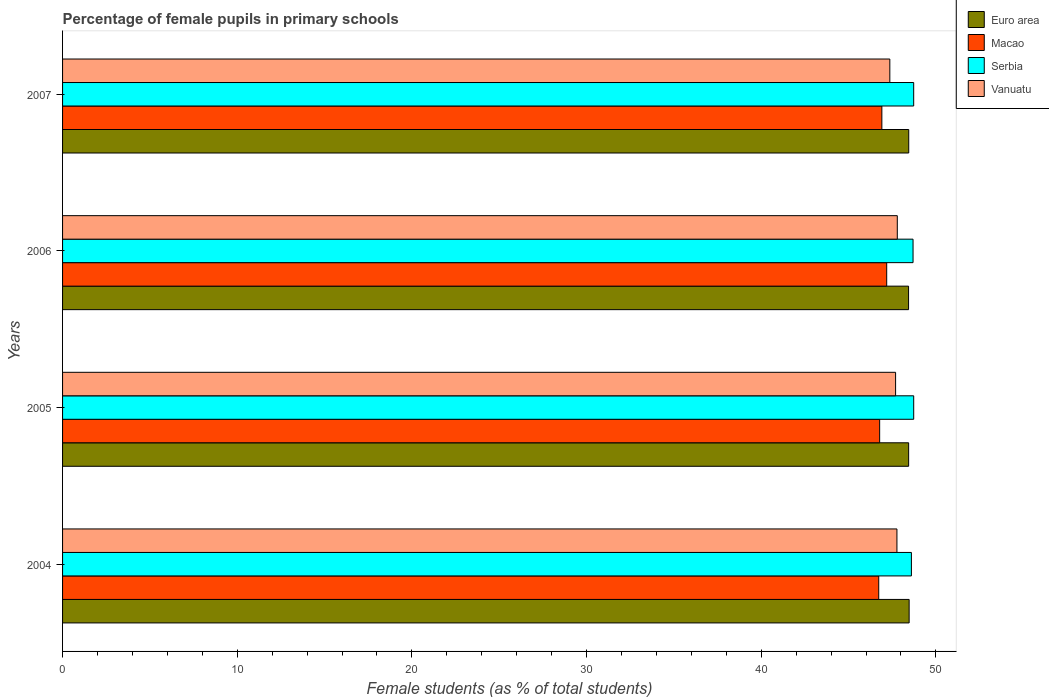How many groups of bars are there?
Provide a short and direct response. 4. How many bars are there on the 4th tick from the top?
Offer a terse response. 4. How many bars are there on the 1st tick from the bottom?
Your response must be concise. 4. What is the percentage of female pupils in primary schools in Macao in 2005?
Offer a terse response. 46.78. Across all years, what is the maximum percentage of female pupils in primary schools in Macao?
Provide a succinct answer. 47.18. Across all years, what is the minimum percentage of female pupils in primary schools in Vanuatu?
Give a very brief answer. 47.36. In which year was the percentage of female pupils in primary schools in Serbia maximum?
Offer a very short reply. 2005. In which year was the percentage of female pupils in primary schools in Euro area minimum?
Offer a very short reply. 2006. What is the total percentage of female pupils in primary schools in Serbia in the graph?
Offer a very short reply. 194.75. What is the difference between the percentage of female pupils in primary schools in Vanuatu in 2005 and that in 2007?
Provide a succinct answer. 0.33. What is the difference between the percentage of female pupils in primary schools in Vanuatu in 2005 and the percentage of female pupils in primary schools in Serbia in 2007?
Provide a short and direct response. -1.04. What is the average percentage of female pupils in primary schools in Macao per year?
Your answer should be very brief. 46.9. In the year 2005, what is the difference between the percentage of female pupils in primary schools in Euro area and percentage of female pupils in primary schools in Vanuatu?
Your answer should be very brief. 0.75. What is the ratio of the percentage of female pupils in primary schools in Vanuatu in 2005 to that in 2007?
Offer a very short reply. 1.01. What is the difference between the highest and the second highest percentage of female pupils in primary schools in Serbia?
Your answer should be very brief. 0. What is the difference between the highest and the lowest percentage of female pupils in primary schools in Serbia?
Offer a very short reply. 0.13. What does the 2nd bar from the top in 2006 represents?
Give a very brief answer. Serbia. What does the 3rd bar from the bottom in 2005 represents?
Keep it short and to the point. Serbia. How many bars are there?
Provide a short and direct response. 16. Does the graph contain any zero values?
Provide a short and direct response. No. Does the graph contain grids?
Provide a short and direct response. No. Where does the legend appear in the graph?
Your response must be concise. Top right. How are the legend labels stacked?
Ensure brevity in your answer.  Vertical. What is the title of the graph?
Ensure brevity in your answer.  Percentage of female pupils in primary schools. What is the label or title of the X-axis?
Your answer should be very brief. Female students (as % of total students). What is the Female students (as % of total students) in Euro area in 2004?
Provide a succinct answer. 48.47. What is the Female students (as % of total students) in Macao in 2004?
Your answer should be compact. 46.73. What is the Female students (as % of total students) of Serbia in 2004?
Your response must be concise. 48.6. What is the Female students (as % of total students) of Vanuatu in 2004?
Your answer should be very brief. 47.77. What is the Female students (as % of total students) of Euro area in 2005?
Offer a very short reply. 48.44. What is the Female students (as % of total students) of Macao in 2005?
Your response must be concise. 46.78. What is the Female students (as % of total students) of Serbia in 2005?
Your response must be concise. 48.73. What is the Female students (as % of total students) in Vanuatu in 2005?
Your response must be concise. 47.69. What is the Female students (as % of total students) of Euro area in 2006?
Your answer should be compact. 48.43. What is the Female students (as % of total students) of Macao in 2006?
Provide a succinct answer. 47.18. What is the Female students (as % of total students) of Serbia in 2006?
Provide a short and direct response. 48.69. What is the Female students (as % of total students) of Vanuatu in 2006?
Your response must be concise. 47.79. What is the Female students (as % of total students) of Euro area in 2007?
Your answer should be very brief. 48.44. What is the Female students (as % of total students) in Macao in 2007?
Give a very brief answer. 46.91. What is the Female students (as % of total students) in Serbia in 2007?
Your answer should be very brief. 48.73. What is the Female students (as % of total students) of Vanuatu in 2007?
Provide a succinct answer. 47.36. Across all years, what is the maximum Female students (as % of total students) of Euro area?
Keep it short and to the point. 48.47. Across all years, what is the maximum Female students (as % of total students) of Macao?
Provide a short and direct response. 47.18. Across all years, what is the maximum Female students (as % of total students) in Serbia?
Offer a very short reply. 48.73. Across all years, what is the maximum Female students (as % of total students) in Vanuatu?
Provide a short and direct response. 47.79. Across all years, what is the minimum Female students (as % of total students) of Euro area?
Keep it short and to the point. 48.43. Across all years, what is the minimum Female students (as % of total students) of Macao?
Ensure brevity in your answer.  46.73. Across all years, what is the minimum Female students (as % of total students) in Serbia?
Give a very brief answer. 48.6. Across all years, what is the minimum Female students (as % of total students) in Vanuatu?
Ensure brevity in your answer.  47.36. What is the total Female students (as % of total students) in Euro area in the graph?
Make the answer very short. 193.79. What is the total Female students (as % of total students) in Macao in the graph?
Offer a very short reply. 187.6. What is the total Female students (as % of total students) of Serbia in the graph?
Keep it short and to the point. 194.75. What is the total Female students (as % of total students) in Vanuatu in the graph?
Give a very brief answer. 190.61. What is the difference between the Female students (as % of total students) of Euro area in 2004 and that in 2005?
Provide a short and direct response. 0.03. What is the difference between the Female students (as % of total students) in Macao in 2004 and that in 2005?
Keep it short and to the point. -0.05. What is the difference between the Female students (as % of total students) of Serbia in 2004 and that in 2005?
Make the answer very short. -0.13. What is the difference between the Female students (as % of total students) of Vanuatu in 2004 and that in 2005?
Your answer should be compact. 0.08. What is the difference between the Female students (as % of total students) in Euro area in 2004 and that in 2006?
Your answer should be compact. 0.03. What is the difference between the Female students (as % of total students) of Macao in 2004 and that in 2006?
Offer a very short reply. -0.46. What is the difference between the Female students (as % of total students) of Serbia in 2004 and that in 2006?
Provide a succinct answer. -0.09. What is the difference between the Female students (as % of total students) in Vanuatu in 2004 and that in 2006?
Offer a terse response. -0.02. What is the difference between the Female students (as % of total students) in Euro area in 2004 and that in 2007?
Your answer should be compact. 0.02. What is the difference between the Female students (as % of total students) of Macao in 2004 and that in 2007?
Your answer should be very brief. -0.18. What is the difference between the Female students (as % of total students) of Serbia in 2004 and that in 2007?
Provide a succinct answer. -0.13. What is the difference between the Female students (as % of total students) of Vanuatu in 2004 and that in 2007?
Offer a terse response. 0.41. What is the difference between the Female students (as % of total students) in Euro area in 2005 and that in 2006?
Make the answer very short. 0. What is the difference between the Female students (as % of total students) in Macao in 2005 and that in 2006?
Your response must be concise. -0.4. What is the difference between the Female students (as % of total students) of Serbia in 2005 and that in 2006?
Your response must be concise. 0.04. What is the difference between the Female students (as % of total students) in Vanuatu in 2005 and that in 2006?
Offer a terse response. -0.1. What is the difference between the Female students (as % of total students) of Euro area in 2005 and that in 2007?
Provide a short and direct response. -0.01. What is the difference between the Female students (as % of total students) of Macao in 2005 and that in 2007?
Keep it short and to the point. -0.13. What is the difference between the Female students (as % of total students) of Serbia in 2005 and that in 2007?
Your answer should be very brief. 0. What is the difference between the Female students (as % of total students) in Vanuatu in 2005 and that in 2007?
Offer a terse response. 0.33. What is the difference between the Female students (as % of total students) of Euro area in 2006 and that in 2007?
Keep it short and to the point. -0.01. What is the difference between the Female students (as % of total students) of Macao in 2006 and that in 2007?
Make the answer very short. 0.28. What is the difference between the Female students (as % of total students) in Serbia in 2006 and that in 2007?
Make the answer very short. -0.04. What is the difference between the Female students (as % of total students) in Vanuatu in 2006 and that in 2007?
Keep it short and to the point. 0.43. What is the difference between the Female students (as % of total students) of Euro area in 2004 and the Female students (as % of total students) of Macao in 2005?
Provide a short and direct response. 1.69. What is the difference between the Female students (as % of total students) of Euro area in 2004 and the Female students (as % of total students) of Serbia in 2005?
Make the answer very short. -0.26. What is the difference between the Female students (as % of total students) in Euro area in 2004 and the Female students (as % of total students) in Vanuatu in 2005?
Provide a short and direct response. 0.78. What is the difference between the Female students (as % of total students) of Macao in 2004 and the Female students (as % of total students) of Serbia in 2005?
Your answer should be compact. -2. What is the difference between the Female students (as % of total students) in Macao in 2004 and the Female students (as % of total students) in Vanuatu in 2005?
Offer a terse response. -0.97. What is the difference between the Female students (as % of total students) in Serbia in 2004 and the Female students (as % of total students) in Vanuatu in 2005?
Give a very brief answer. 0.91. What is the difference between the Female students (as % of total students) in Euro area in 2004 and the Female students (as % of total students) in Macao in 2006?
Keep it short and to the point. 1.28. What is the difference between the Female students (as % of total students) in Euro area in 2004 and the Female students (as % of total students) in Serbia in 2006?
Provide a short and direct response. -0.22. What is the difference between the Female students (as % of total students) of Euro area in 2004 and the Female students (as % of total students) of Vanuatu in 2006?
Your response must be concise. 0.68. What is the difference between the Female students (as % of total students) in Macao in 2004 and the Female students (as % of total students) in Serbia in 2006?
Offer a terse response. -1.96. What is the difference between the Female students (as % of total students) in Macao in 2004 and the Female students (as % of total students) in Vanuatu in 2006?
Provide a succinct answer. -1.06. What is the difference between the Female students (as % of total students) of Serbia in 2004 and the Female students (as % of total students) of Vanuatu in 2006?
Your response must be concise. 0.81. What is the difference between the Female students (as % of total students) of Euro area in 2004 and the Female students (as % of total students) of Macao in 2007?
Make the answer very short. 1.56. What is the difference between the Female students (as % of total students) of Euro area in 2004 and the Female students (as % of total students) of Serbia in 2007?
Provide a short and direct response. -0.26. What is the difference between the Female students (as % of total students) in Euro area in 2004 and the Female students (as % of total students) in Vanuatu in 2007?
Your response must be concise. 1.11. What is the difference between the Female students (as % of total students) in Macao in 2004 and the Female students (as % of total students) in Serbia in 2007?
Keep it short and to the point. -2. What is the difference between the Female students (as % of total students) in Macao in 2004 and the Female students (as % of total students) in Vanuatu in 2007?
Provide a short and direct response. -0.64. What is the difference between the Female students (as % of total students) of Serbia in 2004 and the Female students (as % of total students) of Vanuatu in 2007?
Offer a terse response. 1.24. What is the difference between the Female students (as % of total students) of Euro area in 2005 and the Female students (as % of total students) of Macao in 2006?
Ensure brevity in your answer.  1.26. What is the difference between the Female students (as % of total students) in Euro area in 2005 and the Female students (as % of total students) in Serbia in 2006?
Ensure brevity in your answer.  -0.25. What is the difference between the Female students (as % of total students) in Euro area in 2005 and the Female students (as % of total students) in Vanuatu in 2006?
Give a very brief answer. 0.65. What is the difference between the Female students (as % of total students) in Macao in 2005 and the Female students (as % of total students) in Serbia in 2006?
Provide a succinct answer. -1.91. What is the difference between the Female students (as % of total students) in Macao in 2005 and the Female students (as % of total students) in Vanuatu in 2006?
Offer a very short reply. -1.01. What is the difference between the Female students (as % of total students) in Serbia in 2005 and the Female students (as % of total students) in Vanuatu in 2006?
Provide a succinct answer. 0.94. What is the difference between the Female students (as % of total students) in Euro area in 2005 and the Female students (as % of total students) in Macao in 2007?
Your answer should be compact. 1.53. What is the difference between the Female students (as % of total students) in Euro area in 2005 and the Female students (as % of total students) in Serbia in 2007?
Provide a short and direct response. -0.29. What is the difference between the Female students (as % of total students) in Euro area in 2005 and the Female students (as % of total students) in Vanuatu in 2007?
Offer a very short reply. 1.08. What is the difference between the Female students (as % of total students) of Macao in 2005 and the Female students (as % of total students) of Serbia in 2007?
Provide a short and direct response. -1.95. What is the difference between the Female students (as % of total students) of Macao in 2005 and the Female students (as % of total students) of Vanuatu in 2007?
Ensure brevity in your answer.  -0.58. What is the difference between the Female students (as % of total students) of Serbia in 2005 and the Female students (as % of total students) of Vanuatu in 2007?
Ensure brevity in your answer.  1.37. What is the difference between the Female students (as % of total students) in Euro area in 2006 and the Female students (as % of total students) in Macao in 2007?
Keep it short and to the point. 1.53. What is the difference between the Female students (as % of total students) in Euro area in 2006 and the Female students (as % of total students) in Serbia in 2007?
Offer a terse response. -0.29. What is the difference between the Female students (as % of total students) in Euro area in 2006 and the Female students (as % of total students) in Vanuatu in 2007?
Offer a terse response. 1.07. What is the difference between the Female students (as % of total students) of Macao in 2006 and the Female students (as % of total students) of Serbia in 2007?
Offer a terse response. -1.54. What is the difference between the Female students (as % of total students) in Macao in 2006 and the Female students (as % of total students) in Vanuatu in 2007?
Offer a very short reply. -0.18. What is the difference between the Female students (as % of total students) in Serbia in 2006 and the Female students (as % of total students) in Vanuatu in 2007?
Your response must be concise. 1.33. What is the average Female students (as % of total students) of Euro area per year?
Your response must be concise. 48.45. What is the average Female students (as % of total students) of Macao per year?
Your response must be concise. 46.9. What is the average Female students (as % of total students) of Serbia per year?
Provide a short and direct response. 48.69. What is the average Female students (as % of total students) of Vanuatu per year?
Make the answer very short. 47.65. In the year 2004, what is the difference between the Female students (as % of total students) of Euro area and Female students (as % of total students) of Macao?
Offer a terse response. 1.74. In the year 2004, what is the difference between the Female students (as % of total students) in Euro area and Female students (as % of total students) in Serbia?
Give a very brief answer. -0.13. In the year 2004, what is the difference between the Female students (as % of total students) in Euro area and Female students (as % of total students) in Vanuatu?
Offer a very short reply. 0.7. In the year 2004, what is the difference between the Female students (as % of total students) of Macao and Female students (as % of total students) of Serbia?
Make the answer very short. -1.87. In the year 2004, what is the difference between the Female students (as % of total students) in Macao and Female students (as % of total students) in Vanuatu?
Your answer should be very brief. -1.04. In the year 2004, what is the difference between the Female students (as % of total students) in Serbia and Female students (as % of total students) in Vanuatu?
Give a very brief answer. 0.83. In the year 2005, what is the difference between the Female students (as % of total students) of Euro area and Female students (as % of total students) of Macao?
Provide a succinct answer. 1.66. In the year 2005, what is the difference between the Female students (as % of total students) of Euro area and Female students (as % of total students) of Serbia?
Make the answer very short. -0.29. In the year 2005, what is the difference between the Female students (as % of total students) of Euro area and Female students (as % of total students) of Vanuatu?
Provide a short and direct response. 0.75. In the year 2005, what is the difference between the Female students (as % of total students) in Macao and Female students (as % of total students) in Serbia?
Your answer should be compact. -1.95. In the year 2005, what is the difference between the Female students (as % of total students) of Macao and Female students (as % of total students) of Vanuatu?
Offer a terse response. -0.91. In the year 2005, what is the difference between the Female students (as % of total students) of Serbia and Female students (as % of total students) of Vanuatu?
Your response must be concise. 1.04. In the year 2006, what is the difference between the Female students (as % of total students) in Euro area and Female students (as % of total students) in Macao?
Provide a succinct answer. 1.25. In the year 2006, what is the difference between the Female students (as % of total students) of Euro area and Female students (as % of total students) of Serbia?
Provide a succinct answer. -0.26. In the year 2006, what is the difference between the Female students (as % of total students) in Euro area and Female students (as % of total students) in Vanuatu?
Offer a terse response. 0.64. In the year 2006, what is the difference between the Female students (as % of total students) of Macao and Female students (as % of total students) of Serbia?
Keep it short and to the point. -1.51. In the year 2006, what is the difference between the Female students (as % of total students) in Macao and Female students (as % of total students) in Vanuatu?
Offer a very short reply. -0.61. In the year 2006, what is the difference between the Female students (as % of total students) of Serbia and Female students (as % of total students) of Vanuatu?
Offer a terse response. 0.9. In the year 2007, what is the difference between the Female students (as % of total students) of Euro area and Female students (as % of total students) of Macao?
Your answer should be compact. 1.54. In the year 2007, what is the difference between the Female students (as % of total students) of Euro area and Female students (as % of total students) of Serbia?
Your answer should be compact. -0.28. In the year 2007, what is the difference between the Female students (as % of total students) of Euro area and Female students (as % of total students) of Vanuatu?
Make the answer very short. 1.08. In the year 2007, what is the difference between the Female students (as % of total students) in Macao and Female students (as % of total students) in Serbia?
Provide a succinct answer. -1.82. In the year 2007, what is the difference between the Female students (as % of total students) of Macao and Female students (as % of total students) of Vanuatu?
Keep it short and to the point. -0.46. In the year 2007, what is the difference between the Female students (as % of total students) in Serbia and Female students (as % of total students) in Vanuatu?
Give a very brief answer. 1.37. What is the ratio of the Female students (as % of total students) in Euro area in 2004 to that in 2006?
Ensure brevity in your answer.  1. What is the ratio of the Female students (as % of total students) in Macao in 2004 to that in 2006?
Provide a succinct answer. 0.99. What is the ratio of the Female students (as % of total students) of Serbia in 2004 to that in 2006?
Ensure brevity in your answer.  1. What is the ratio of the Female students (as % of total students) in Vanuatu in 2004 to that in 2006?
Keep it short and to the point. 1. What is the ratio of the Female students (as % of total students) in Euro area in 2004 to that in 2007?
Give a very brief answer. 1. What is the ratio of the Female students (as % of total students) in Macao in 2004 to that in 2007?
Provide a succinct answer. 1. What is the ratio of the Female students (as % of total students) of Serbia in 2004 to that in 2007?
Your answer should be compact. 1. What is the ratio of the Female students (as % of total students) of Vanuatu in 2004 to that in 2007?
Your response must be concise. 1.01. What is the ratio of the Female students (as % of total students) of Macao in 2005 to that in 2006?
Offer a terse response. 0.99. What is the ratio of the Female students (as % of total students) of Vanuatu in 2005 to that in 2006?
Keep it short and to the point. 1. What is the ratio of the Female students (as % of total students) in Euro area in 2005 to that in 2007?
Provide a short and direct response. 1. What is the ratio of the Female students (as % of total students) in Vanuatu in 2005 to that in 2007?
Your response must be concise. 1.01. What is the ratio of the Female students (as % of total students) in Euro area in 2006 to that in 2007?
Provide a succinct answer. 1. What is the ratio of the Female students (as % of total students) in Macao in 2006 to that in 2007?
Make the answer very short. 1.01. What is the difference between the highest and the second highest Female students (as % of total students) in Euro area?
Offer a terse response. 0.02. What is the difference between the highest and the second highest Female students (as % of total students) of Macao?
Give a very brief answer. 0.28. What is the difference between the highest and the second highest Female students (as % of total students) of Serbia?
Your answer should be compact. 0. What is the difference between the highest and the second highest Female students (as % of total students) in Vanuatu?
Give a very brief answer. 0.02. What is the difference between the highest and the lowest Female students (as % of total students) in Euro area?
Your response must be concise. 0.03. What is the difference between the highest and the lowest Female students (as % of total students) in Macao?
Your answer should be very brief. 0.46. What is the difference between the highest and the lowest Female students (as % of total students) of Serbia?
Make the answer very short. 0.13. What is the difference between the highest and the lowest Female students (as % of total students) in Vanuatu?
Provide a short and direct response. 0.43. 